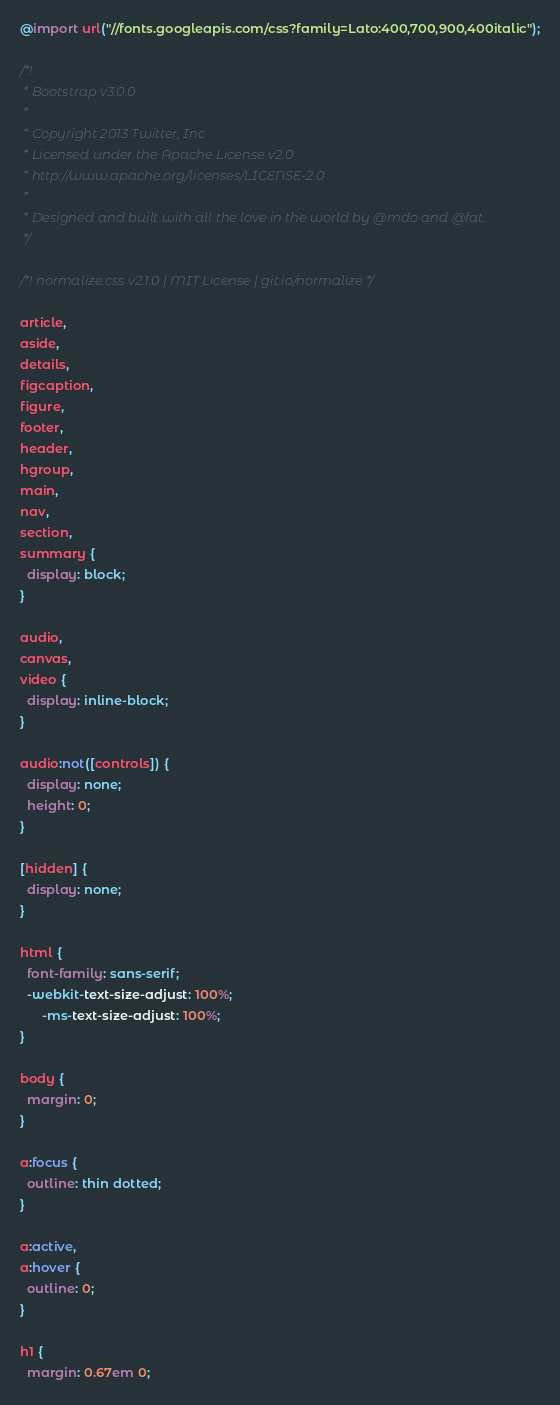Convert code to text. <code><loc_0><loc_0><loc_500><loc_500><_CSS_>@import url("//fonts.googleapis.com/css?family=Lato:400,700,900,400italic");

/*!
 * Bootstrap v3.0.0
 *
 * Copyright 2013 Twitter, Inc
 * Licensed under the Apache License v2.0
 * http://www.apache.org/licenses/LICENSE-2.0
 *
 * Designed and built with all the love in the world by @mdo and @fat.
 */

/*! normalize.css v2.1.0 | MIT License | git.io/normalize */

article,
aside,
details,
figcaption,
figure,
footer,
header,
hgroup,
main,
nav,
section,
summary {
  display: block;
}

audio,
canvas,
video {
  display: inline-block;
}

audio:not([controls]) {
  display: none;
  height: 0;
}

[hidden] {
  display: none;
}

html {
  font-family: sans-serif;
  -webkit-text-size-adjust: 100%;
      -ms-text-size-adjust: 100%;
}

body {
  margin: 0;
}

a:focus {
  outline: thin dotted;
}

a:active,
a:hover {
  outline: 0;
}

h1 {
  margin: 0.67em 0;</code> 